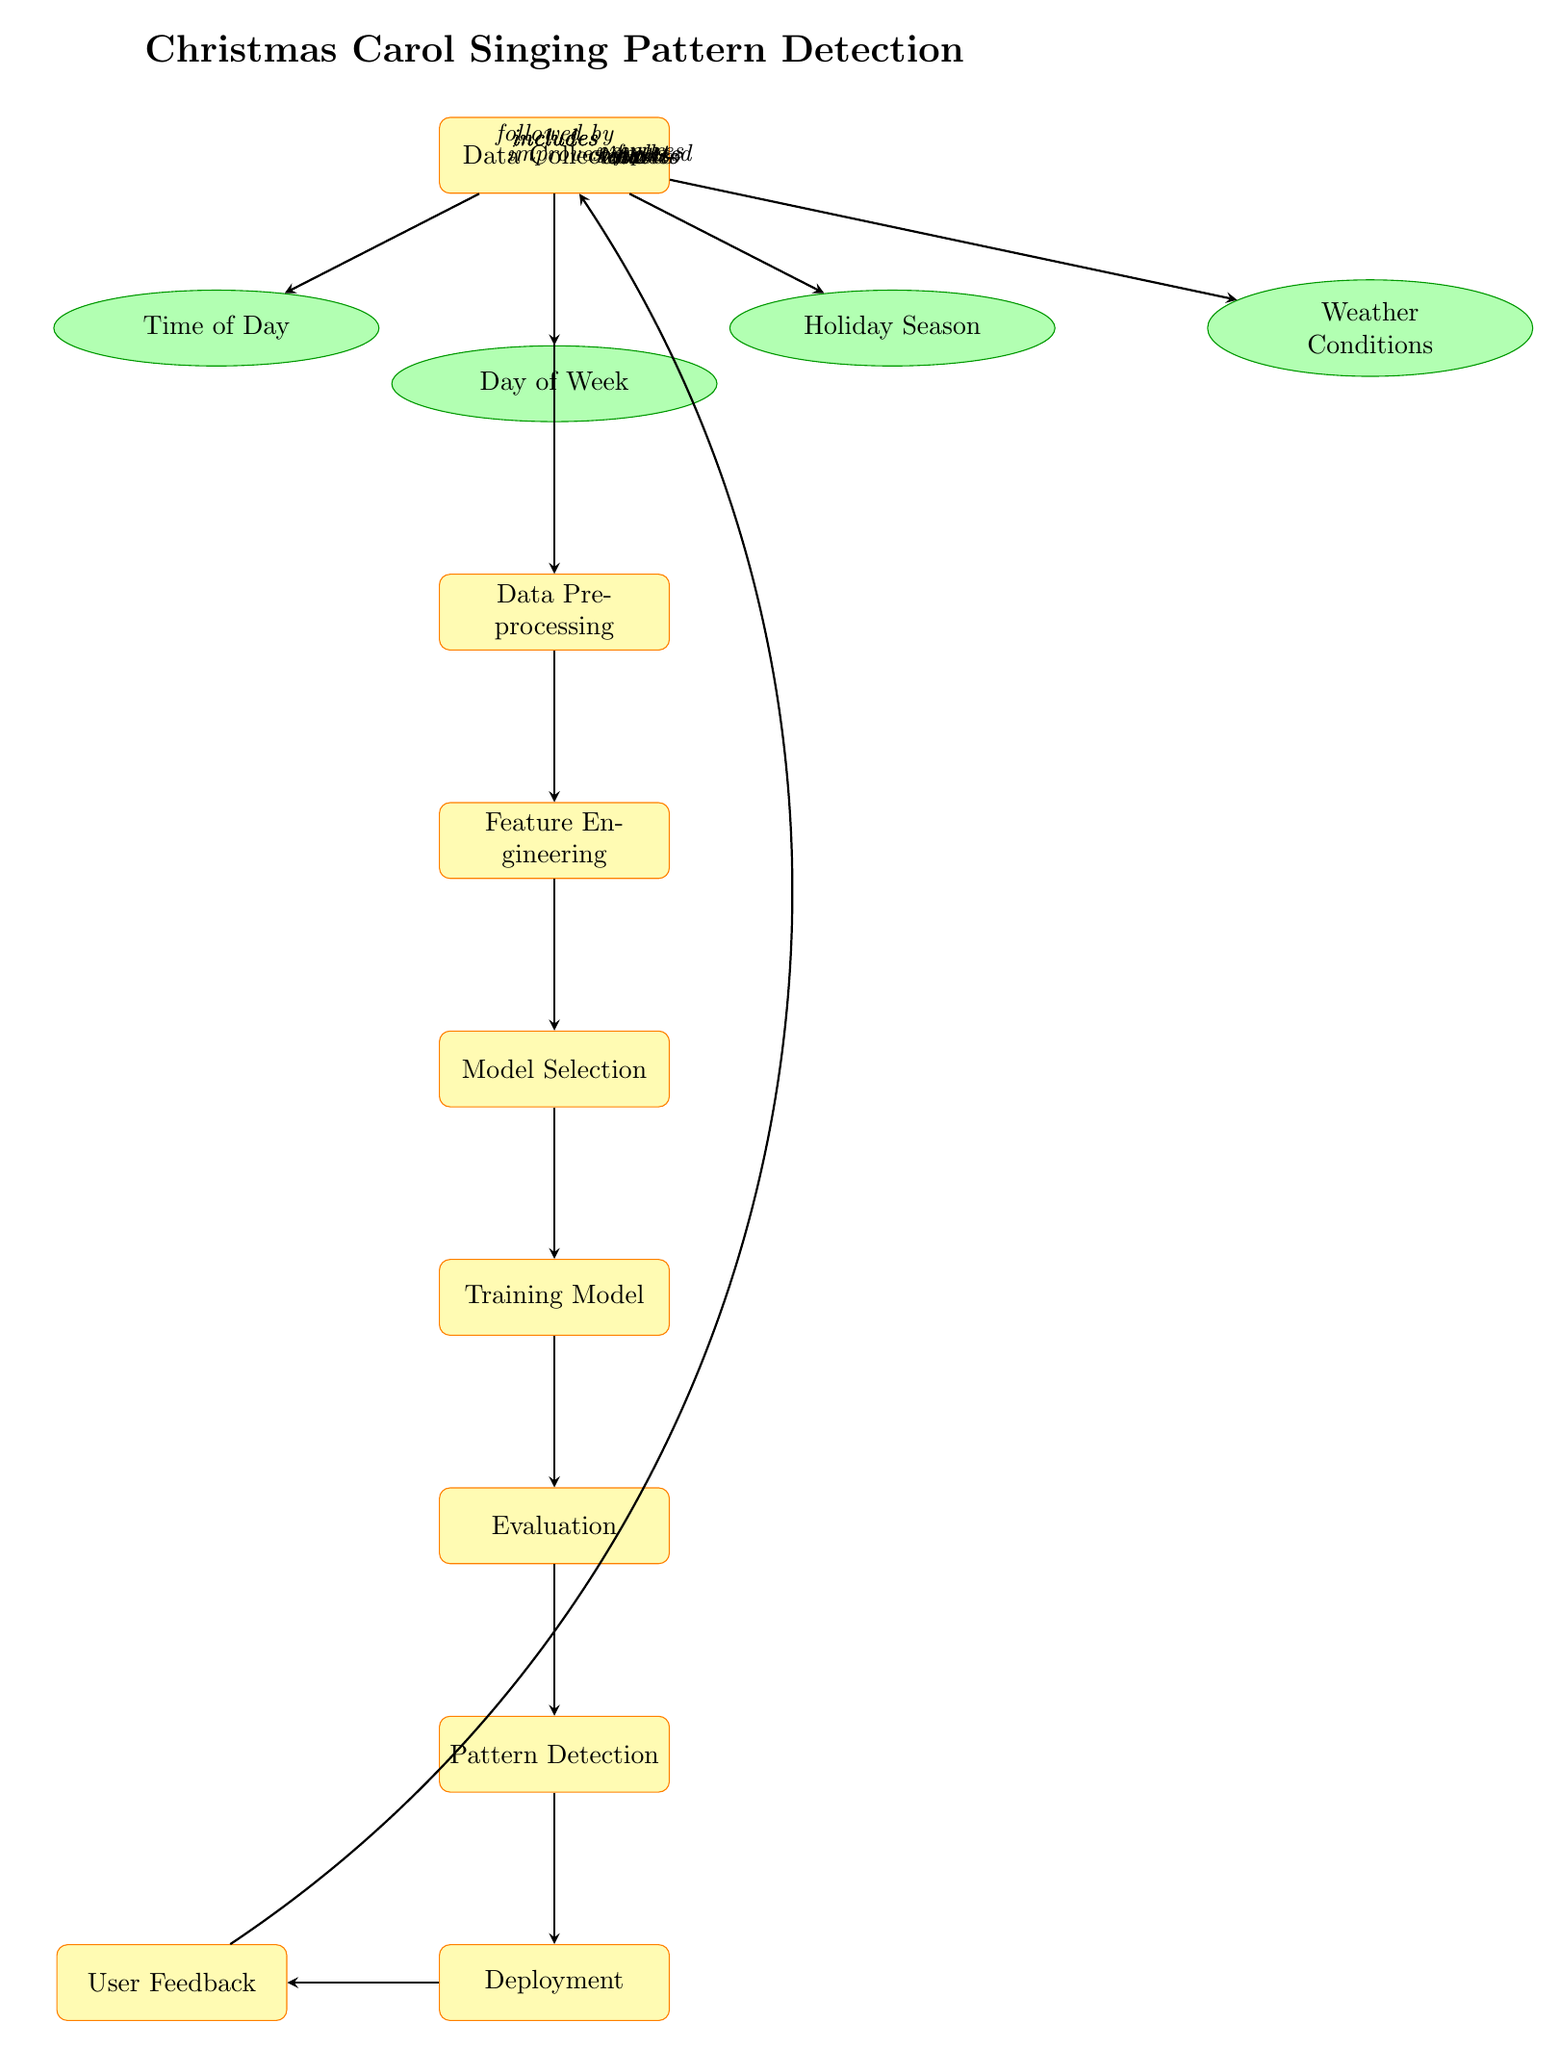What is the first process in the diagram? The first process in the diagram is labeled as "Data Collection," which is visually at the top of the diagram.
Answer: Data Collection How many data nodes are present in the diagram? There are four data nodes in the diagram: Time of Day, Day of Week, Holiday Season, and Weather Conditions. Counting these nodes gives a total of four.
Answer: 4 What does the "preprocessing" process do? The "preprocessing" process receives inputs from the "Data Collection" node and prepares these inputs for the next step, which is "Feature Engineering." This process is crucial as it makes data usable.
Answer: prepares Which process comes after "Model Selection"? The process that comes after "Model Selection" is "Training Model." This can be inferred by following the arrows in a downward direction from "Model Selection."
Answer: Training Model How does "User Feedback" affect the diagram? "User Feedback" improves the "Data Collection" process, creating a feedback loop to refine the data that is collected based on user input. This is indicated by the arrow bending back to "Data Collection."
Answer: improves What are the overall steps depicted in this diagram? The diagram presents a sequence of operations starting from "Data Collection" leading through "Preprocessing," "Feature Engineering," "Model Selection," "Training Model," "Evaluation," and finally reaching "Pattern Detection" followed by "Deployment." This shows how data flows through the system.
Answer: Data Collection, Preprocessing, Feature Engineering, Model Selection, Training Model, Evaluation, Pattern Detection, Deployment What is the last step before deployment? The last step before deployment is "Pattern Detection," which follows the "Evaluation" process according to the arrows' direction. This step determines the patterns before the final deployment stage.
Answer: Pattern Detection Which data node to the right of the "holiday season" is present? The data node immediately to the right of the "Holiday Season" is "Weather Conditions." This can be observed in the layout of the diagram where nodes are positioned relative to one another.
Answer: Weather Conditions In what way does "Evaluation" relate to "Pattern Detection"? "Evaluation" leads to "Pattern Detection," indicating that the results of the evaluation process are essential for identifying patterns in the data. This connection is indicated by the arrow connecting these two processes.
Answer: leads to 